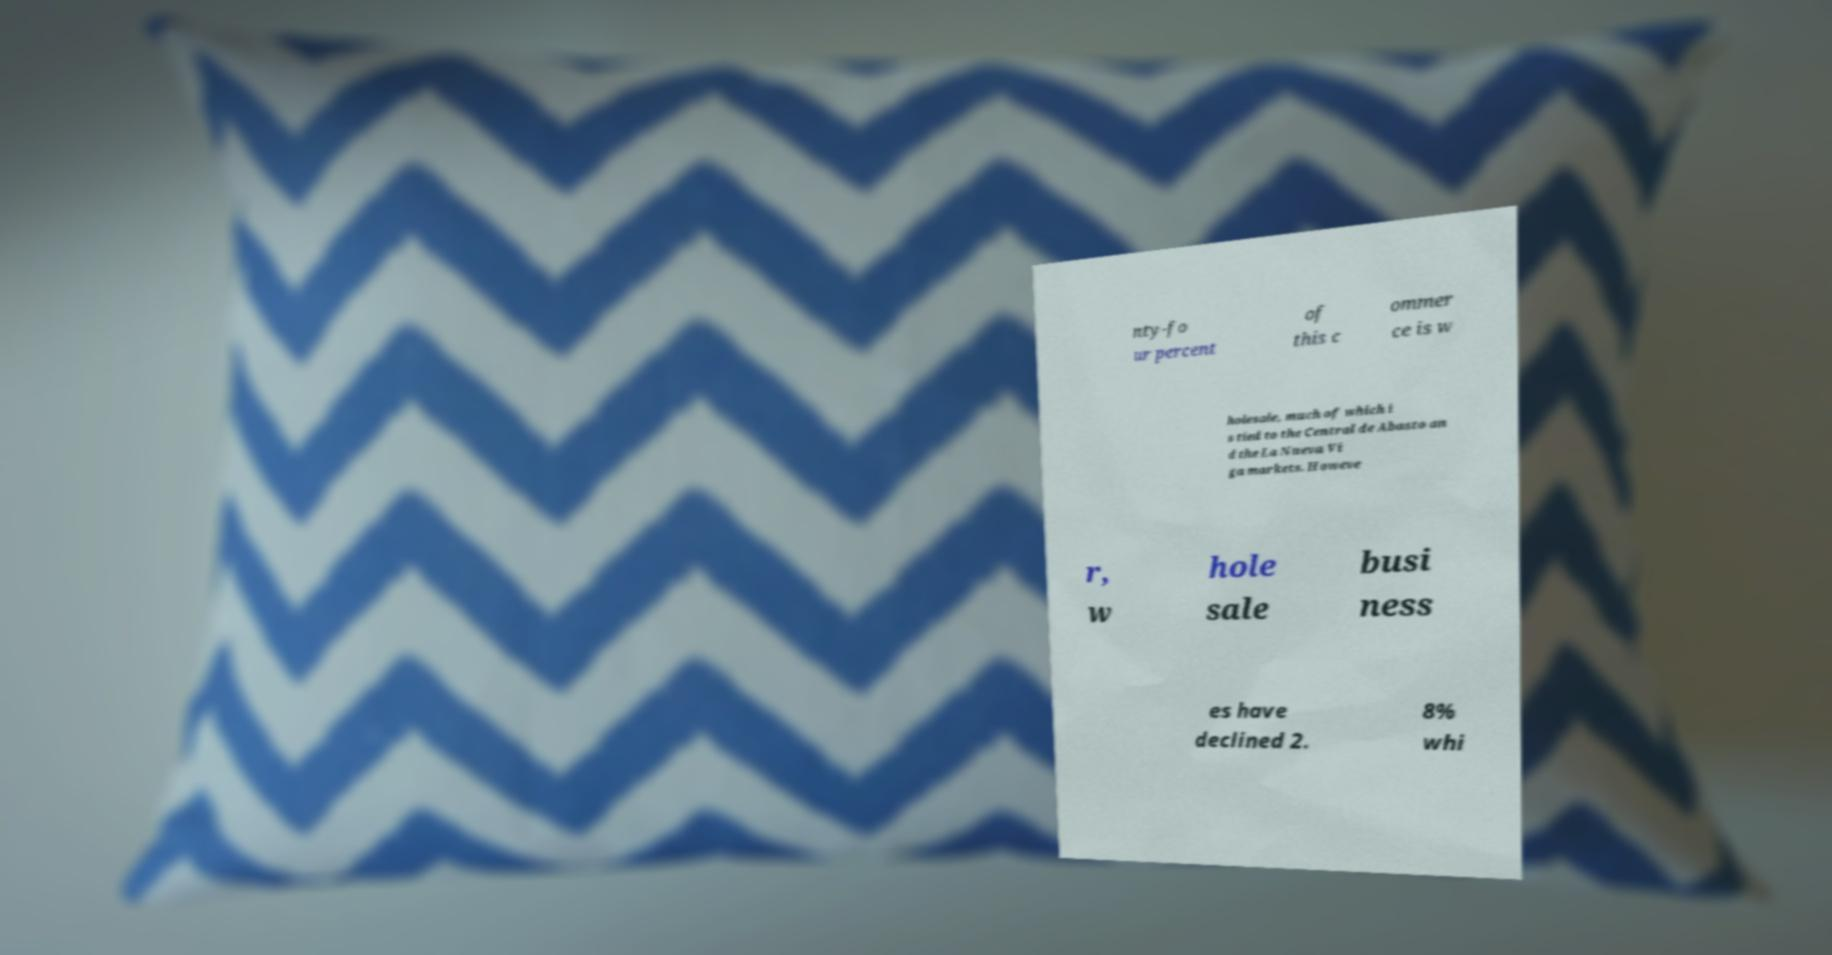For documentation purposes, I need the text within this image transcribed. Could you provide that? nty-fo ur percent of this c ommer ce is w holesale, much of which i s tied to the Central de Abasto an d the La Nueva Vi ga markets. Howeve r, w hole sale busi ness es have declined 2. 8% whi 